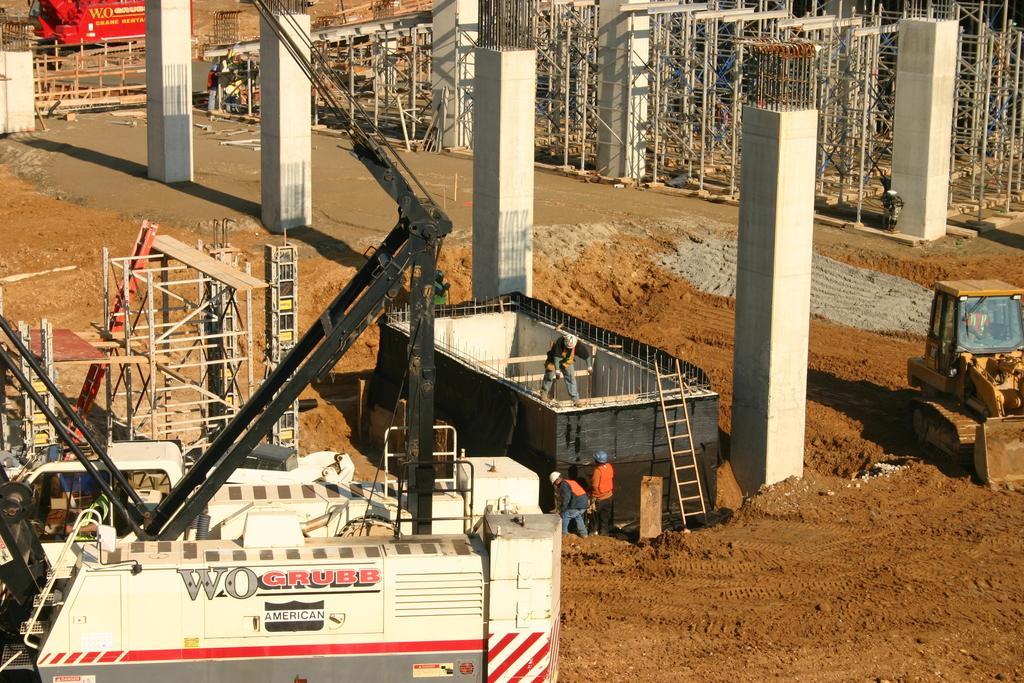Could you give a brief overview of what you see in this image? In this picture we can see pillars here, at the bottom there is soil, on the right side there is a bulldozer, we can see a ladder here, in the background there are some metal rods, we can see three persons standing here. 